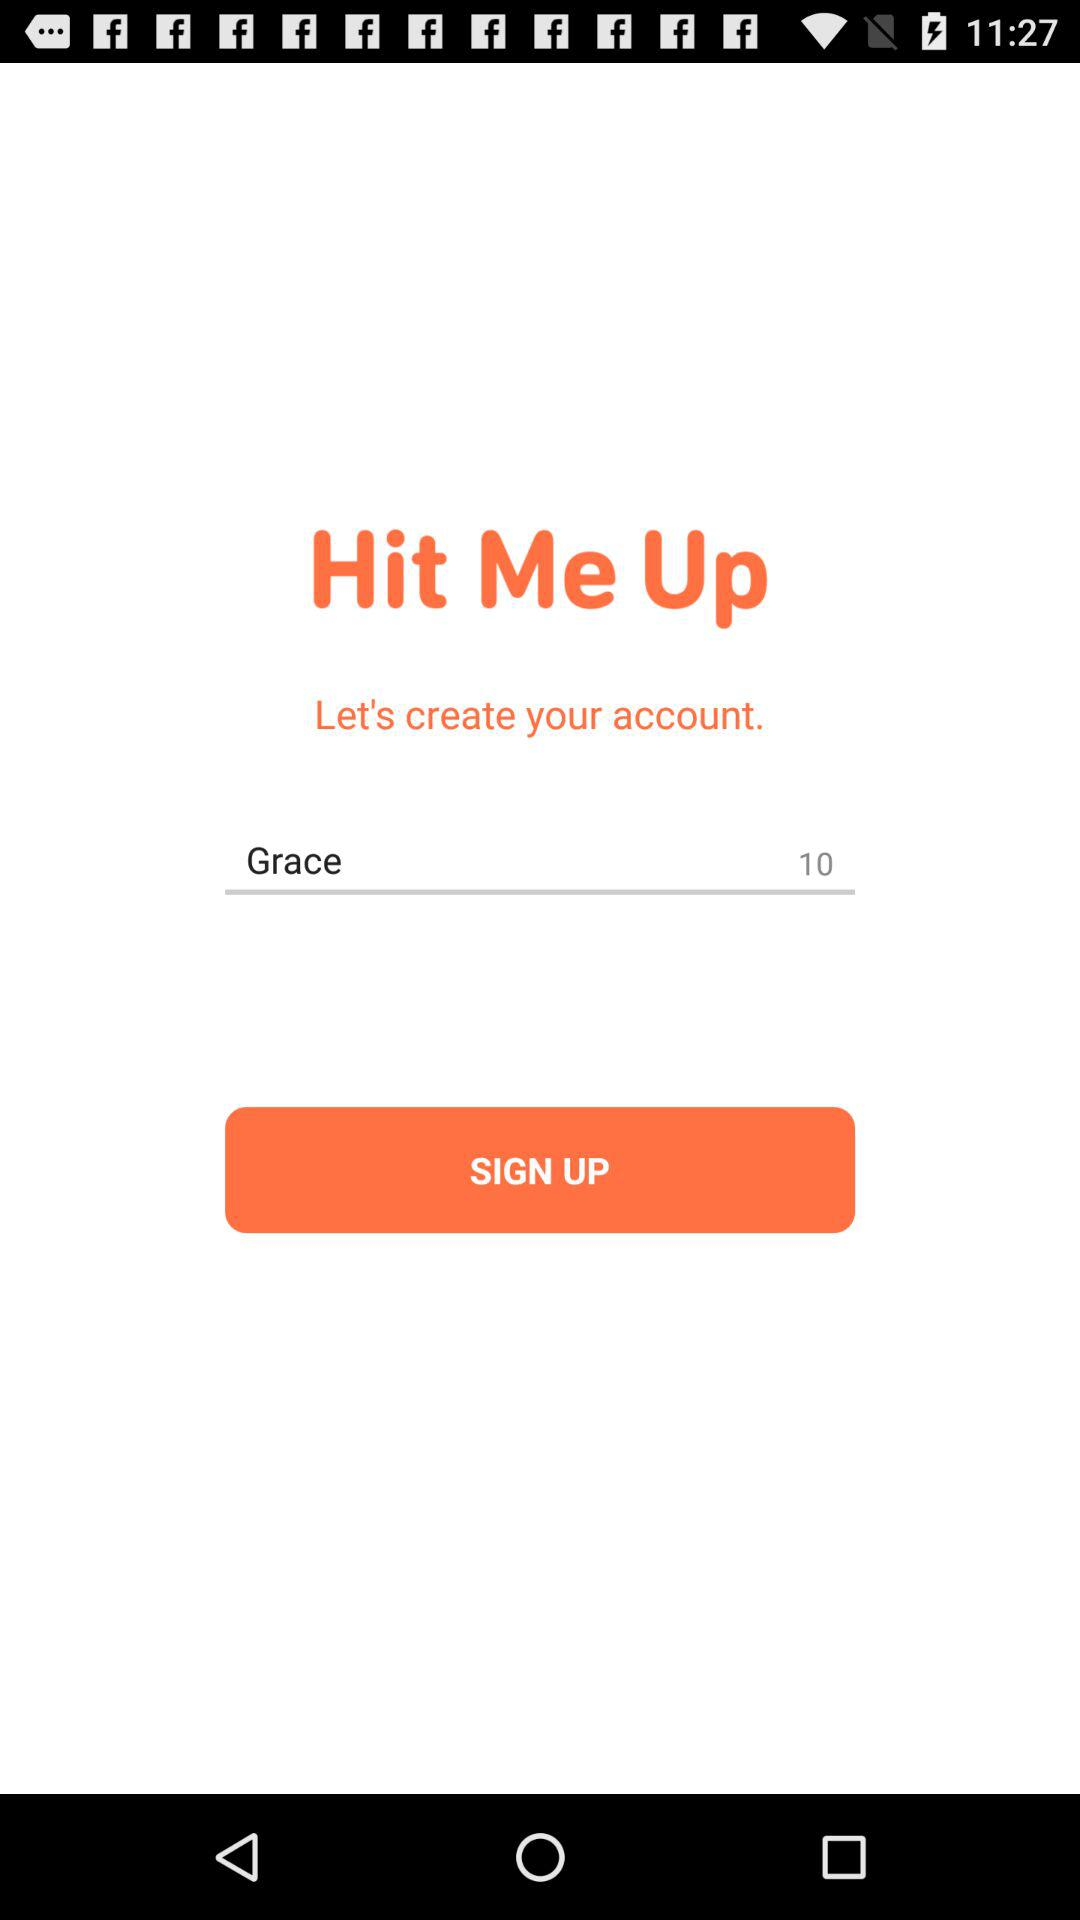When is "Grace" creating a "Hit Me Up" account?
When the provided information is insufficient, respond with <no answer>. <no answer> 